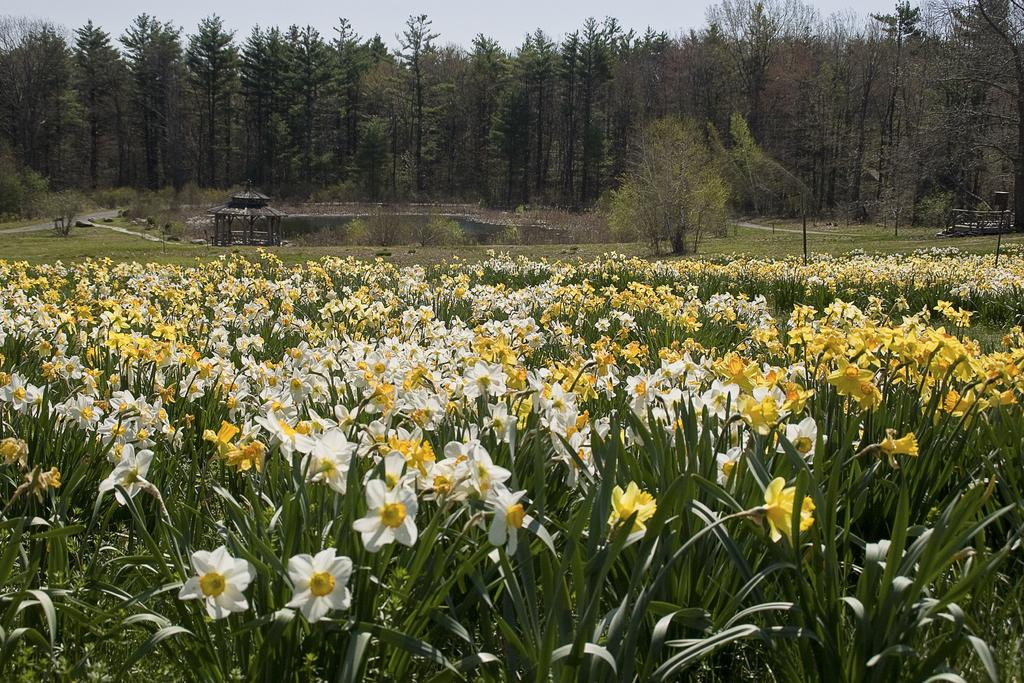What type of plants can be seen in the image? There are flower plants in the image. What colors are the flowers? The flowers are white and yellow in color. What type of vegetation is visible besides the flower plants? There is grass visible in the image. What other natural elements can be seen in the image? There are trees and water visible in the image. What is visible in the background of the image? The sky is visible in the image. What time of day is represented by the morning light in the image? There is no mention of morning light or any specific time of day in the image. The sky is visible, but no indication of time is given. 